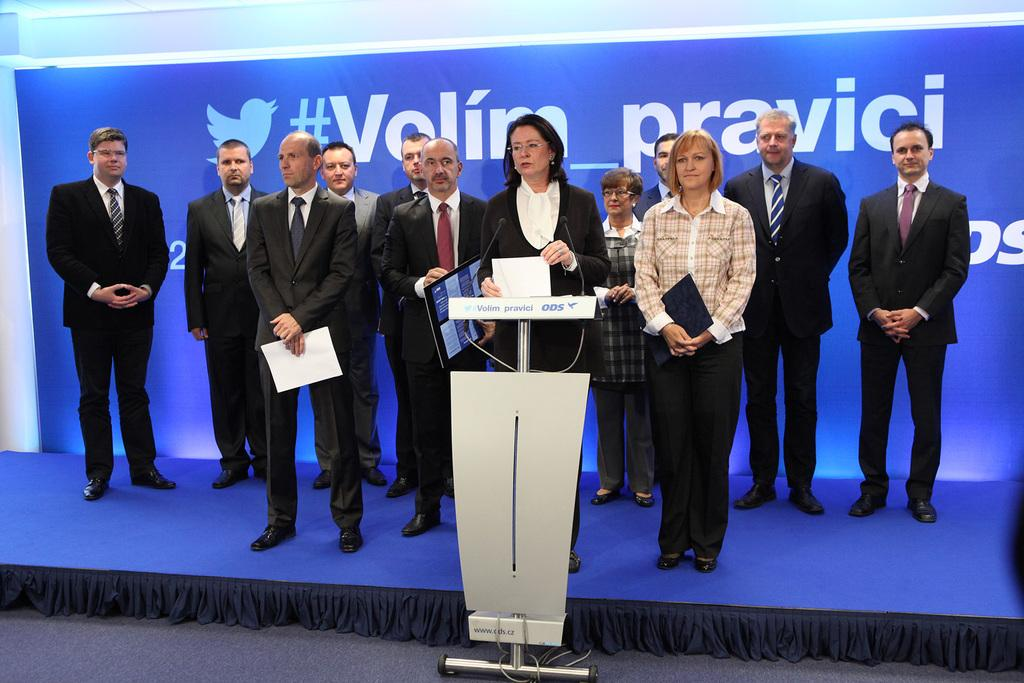What is happening in the image? There is a group of people in the image, and they are standing on a stage. Can you describe the woman in the image? The woman is holding a paper in her hands and is standing at a podium. What can be seen in the background of the image? There is a banner visible in the background. Is there a donkey on fire in the image? No, there is no donkey or fire present in the image. 